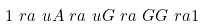Convert formula to latex. <formula><loc_0><loc_0><loc_500><loc_500>1 \ r a \ u A \ r a \ u G \ r a \ G G \ r a 1</formula> 